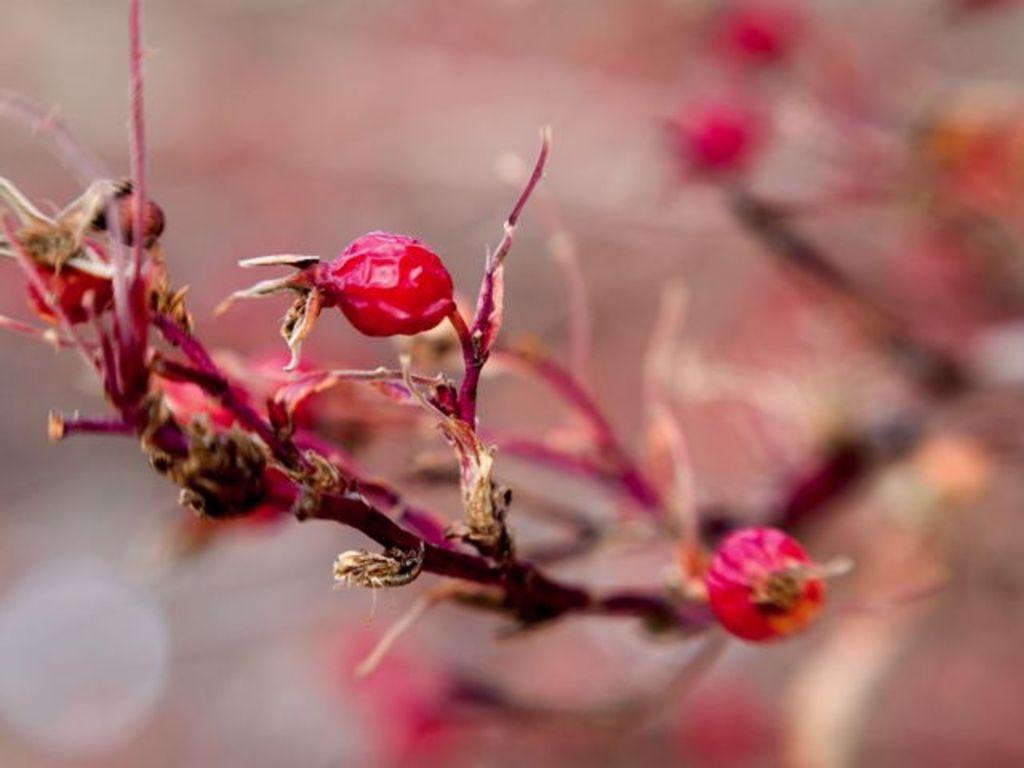Could you give a brief overview of what you see in this image? In this image I see the stems on which there are red color things and I see that it is blurred in the background. 